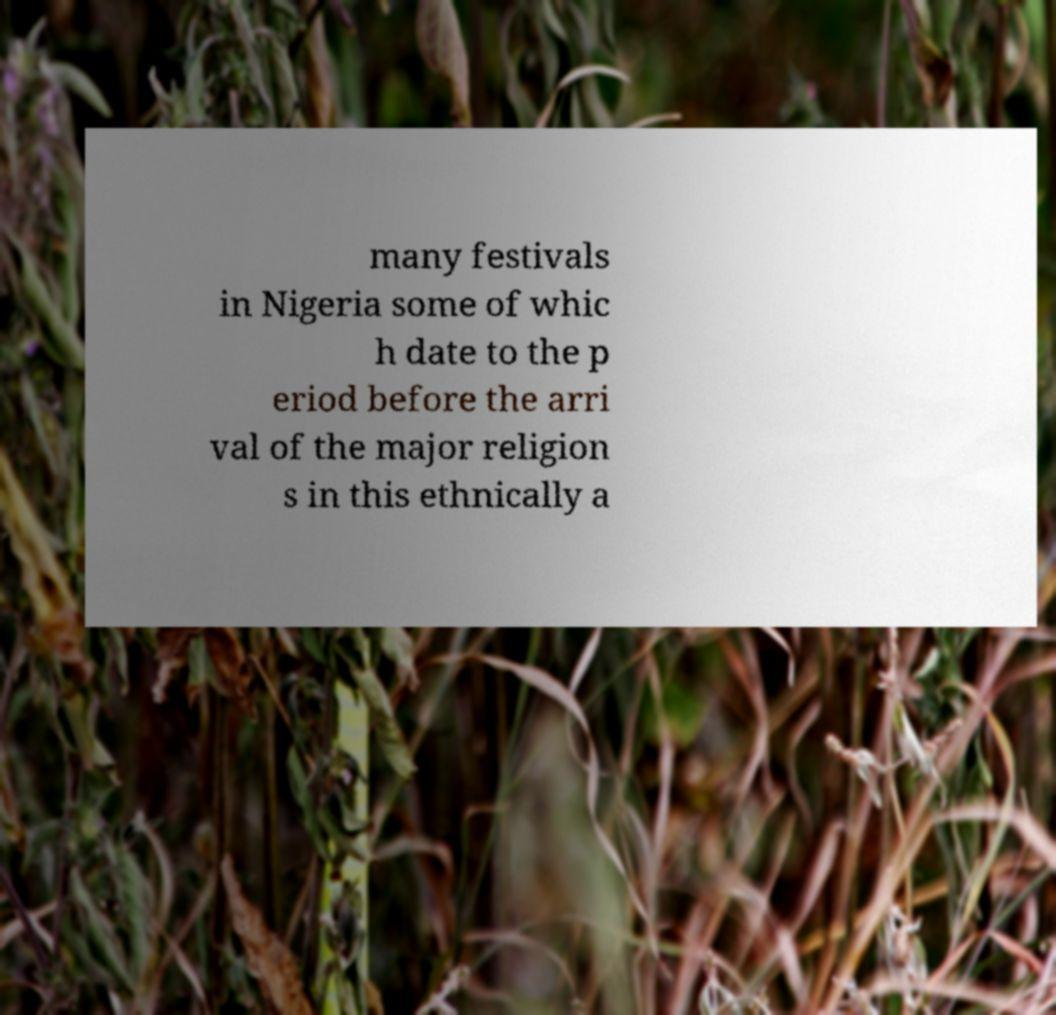Please identify and transcribe the text found in this image. many festivals in Nigeria some of whic h date to the p eriod before the arri val of the major religion s in this ethnically a 